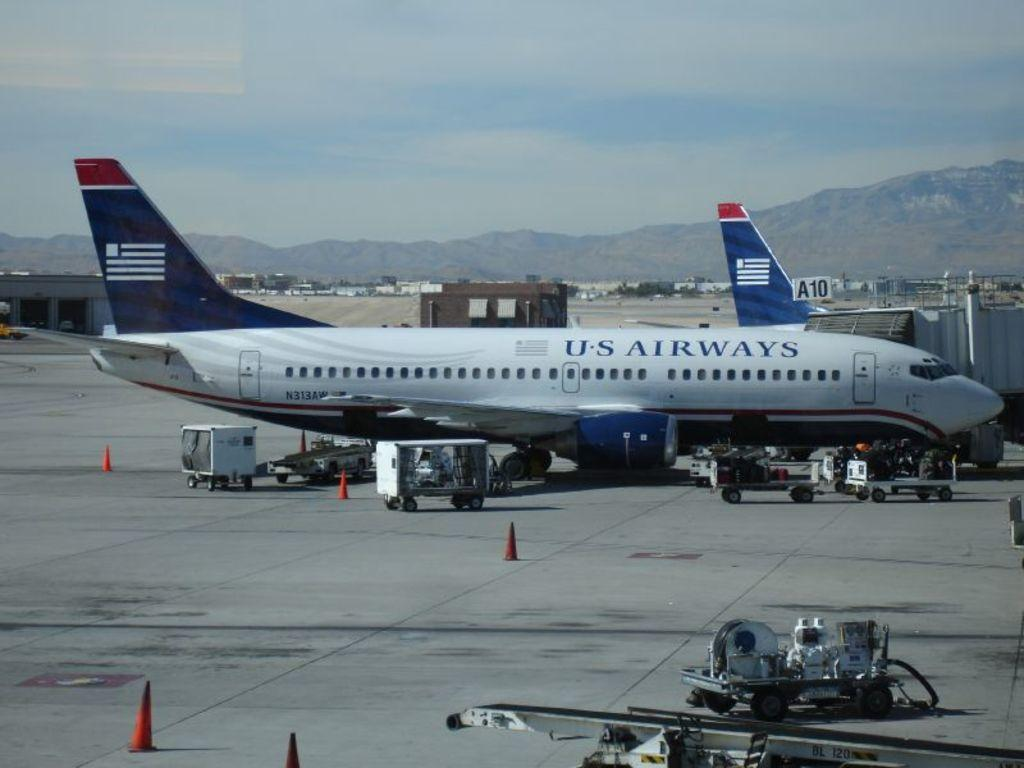<image>
Present a compact description of the photo's key features. U.S Airways blue, red, and white airplane on ground. 